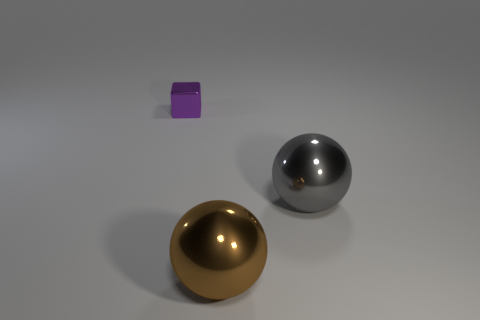Are there any other things that have the same shape as the brown shiny thing?
Your answer should be compact. Yes. What color is the other object that is the same shape as the gray metallic thing?
Your answer should be compact. Brown. The gray thing has what size?
Your answer should be very brief. Large. Are there fewer small metallic objects in front of the large gray object than metal objects?
Offer a terse response. Yes. Is the purple cube made of the same material as the sphere on the left side of the gray ball?
Your response must be concise. Yes. Are there any tiny blocks in front of the sphere that is in front of the large object behind the large brown shiny thing?
Keep it short and to the point. No. Are there any other things that are the same size as the purple shiny block?
Offer a terse response. No. There is a small block that is the same material as the gray object; what is its color?
Give a very brief answer. Purple. How big is the shiny object that is both behind the big brown metal ball and to the right of the small metal object?
Provide a succinct answer. Large. Are there fewer objects that are to the right of the large brown metallic sphere than purple metal cubes that are on the left side of the small purple cube?
Your answer should be very brief. No. 